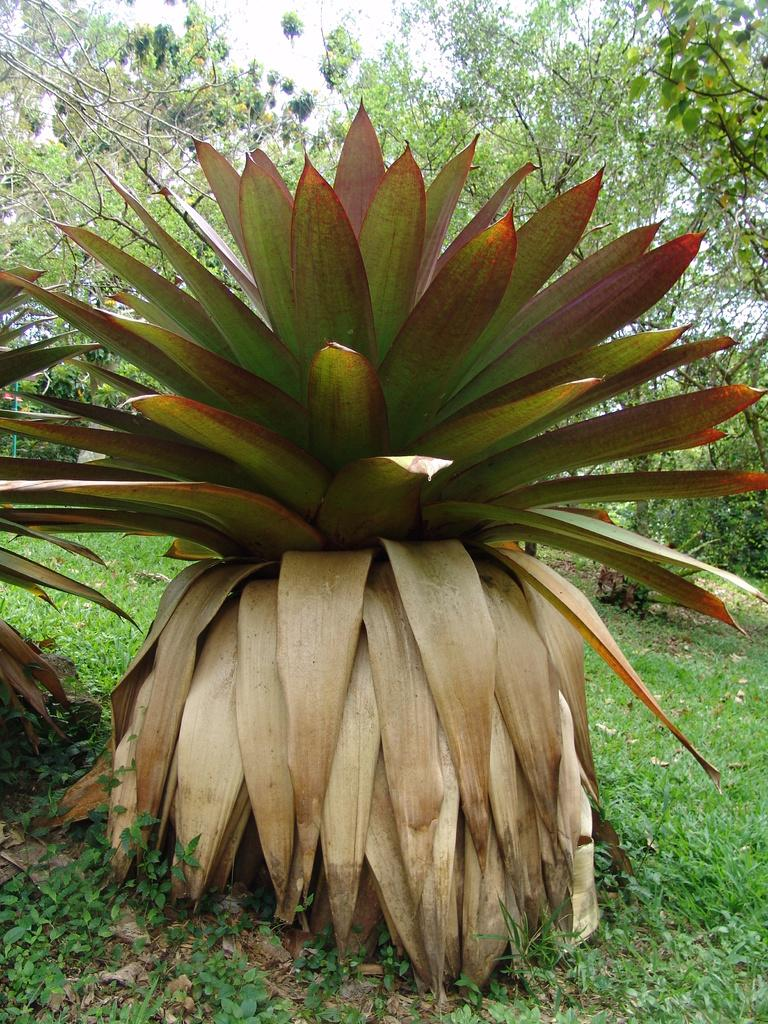What type of vegetation can be seen in the image? There are many trees, plants, and grass visible in the image. Where are the leaves located in the image? The leaves are visible on the left side of the image. What is visible at the top of the image? The sky is visible at the top of the image. Where is the camera placed in the image? There is no camera present in the image. What type of furniture can be seen in the image? There is no furniture, such as a table or sofa, present in the image. 